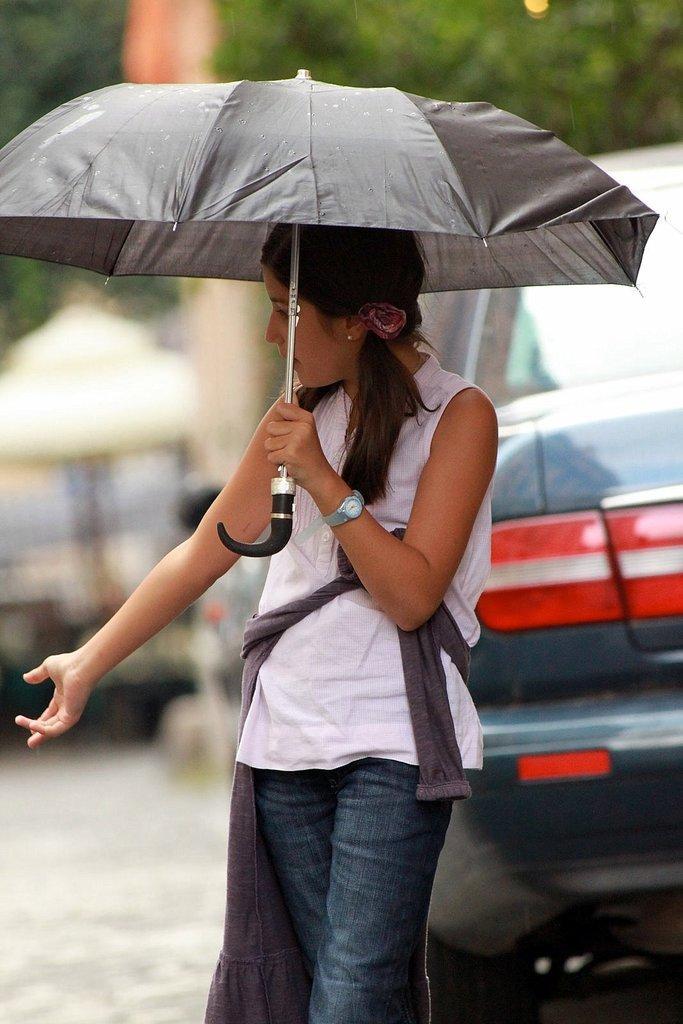How would you summarize this image in a sentence or two? In this image there is a lady standing and holding an umbrella, behind the lady there is a car. In the background there are trees. 